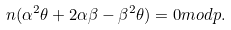Convert formula to latex. <formula><loc_0><loc_0><loc_500><loc_500>n ( \alpha ^ { 2 } \theta + 2 \alpha \beta - \beta ^ { 2 } \theta ) = 0 m o d p .</formula> 